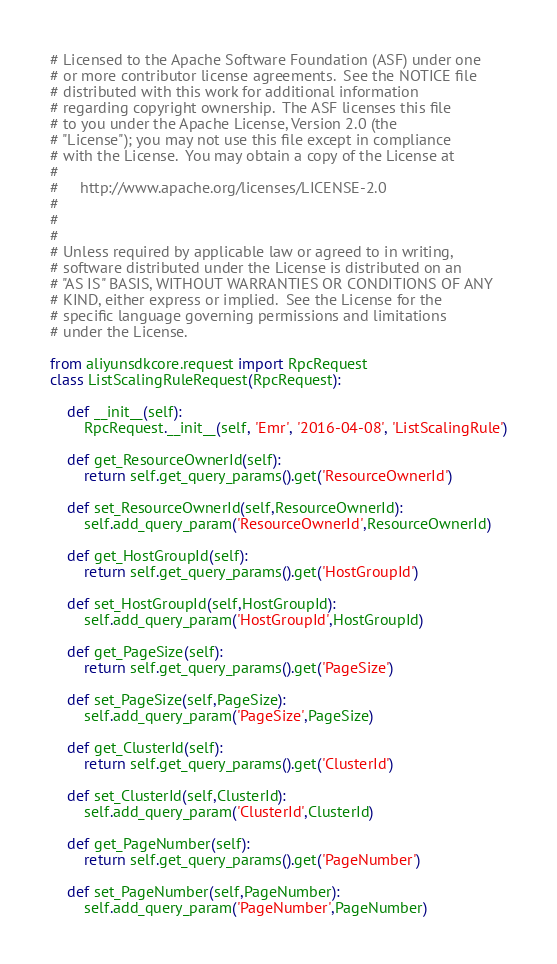Convert code to text. <code><loc_0><loc_0><loc_500><loc_500><_Python_># Licensed to the Apache Software Foundation (ASF) under one
# or more contributor license agreements.  See the NOTICE file
# distributed with this work for additional information
# regarding copyright ownership.  The ASF licenses this file
# to you under the Apache License, Version 2.0 (the
# "License"); you may not use this file except in compliance
# with the License.  You may obtain a copy of the License at
#
#     http://www.apache.org/licenses/LICENSE-2.0
#
#
#
# Unless required by applicable law or agreed to in writing,
# software distributed under the License is distributed on an
# "AS IS" BASIS, WITHOUT WARRANTIES OR CONDITIONS OF ANY
# KIND, either express or implied.  See the License for the
# specific language governing permissions and limitations
# under the License.

from aliyunsdkcore.request import RpcRequest
class ListScalingRuleRequest(RpcRequest):

	def __init__(self):
		RpcRequest.__init__(self, 'Emr', '2016-04-08', 'ListScalingRule')

	def get_ResourceOwnerId(self):
		return self.get_query_params().get('ResourceOwnerId')

	def set_ResourceOwnerId(self,ResourceOwnerId):
		self.add_query_param('ResourceOwnerId',ResourceOwnerId)

	def get_HostGroupId(self):
		return self.get_query_params().get('HostGroupId')

	def set_HostGroupId(self,HostGroupId):
		self.add_query_param('HostGroupId',HostGroupId)

	def get_PageSize(self):
		return self.get_query_params().get('PageSize')

	def set_PageSize(self,PageSize):
		self.add_query_param('PageSize',PageSize)

	def get_ClusterId(self):
		return self.get_query_params().get('ClusterId')

	def set_ClusterId(self,ClusterId):
		self.add_query_param('ClusterId',ClusterId)

	def get_PageNumber(self):
		return self.get_query_params().get('PageNumber')

	def set_PageNumber(self,PageNumber):
		self.add_query_param('PageNumber',PageNumber)</code> 